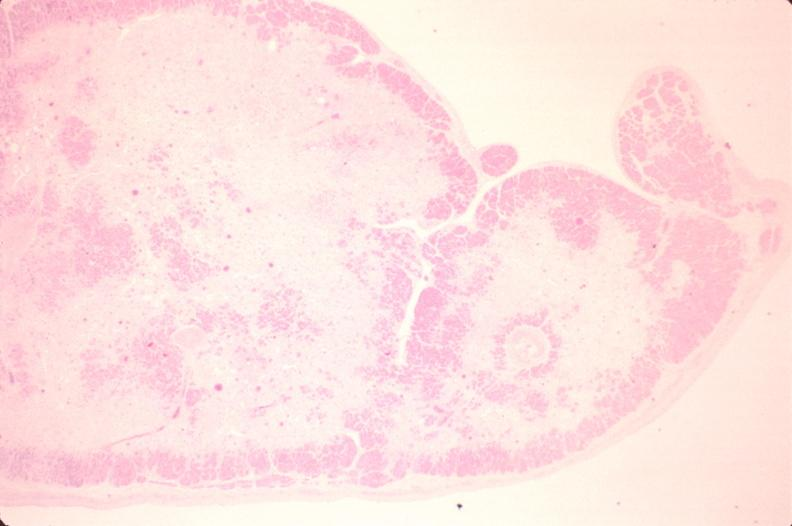what is present?
Answer the question using a single word or phrase. Cardiovascular 